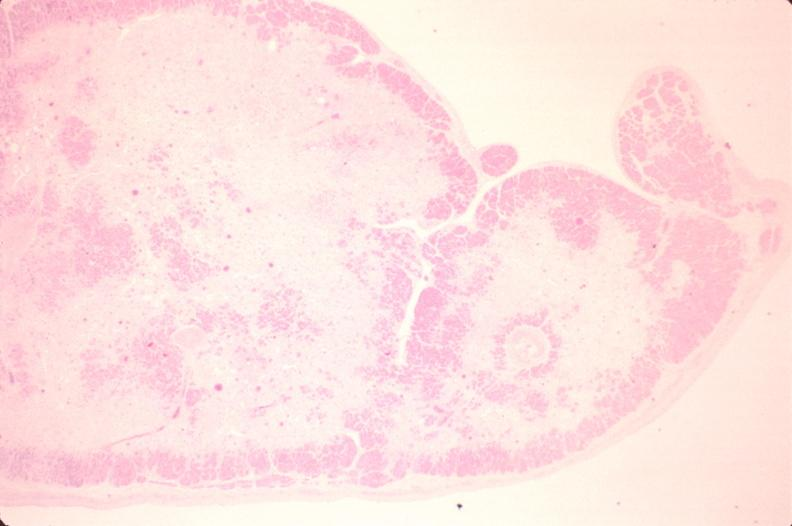what is present?
Answer the question using a single word or phrase. Cardiovascular 